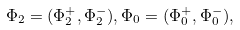<formula> <loc_0><loc_0><loc_500><loc_500>\Phi _ { 2 } = ( \Phi _ { 2 } ^ { + } , \Phi _ { 2 } ^ { - } ) , \Phi _ { 0 } = ( \Phi _ { 0 } ^ { + } , \Phi _ { 0 } ^ { - } ) ,</formula> 